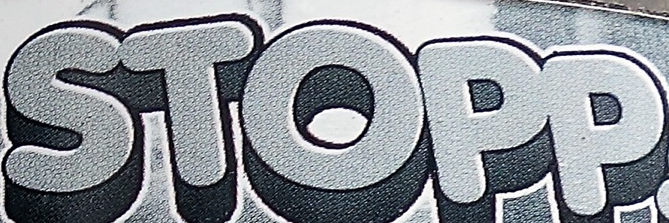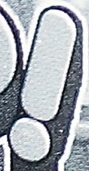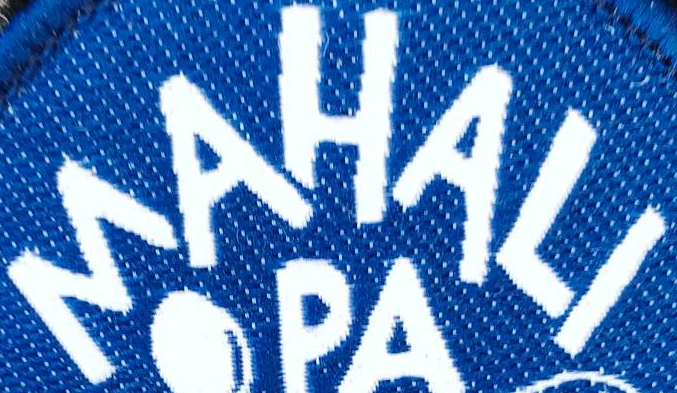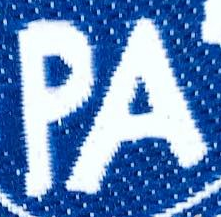What words can you see in these images in sequence, separated by a semicolon? STOPP; !; MAHALI; PA 